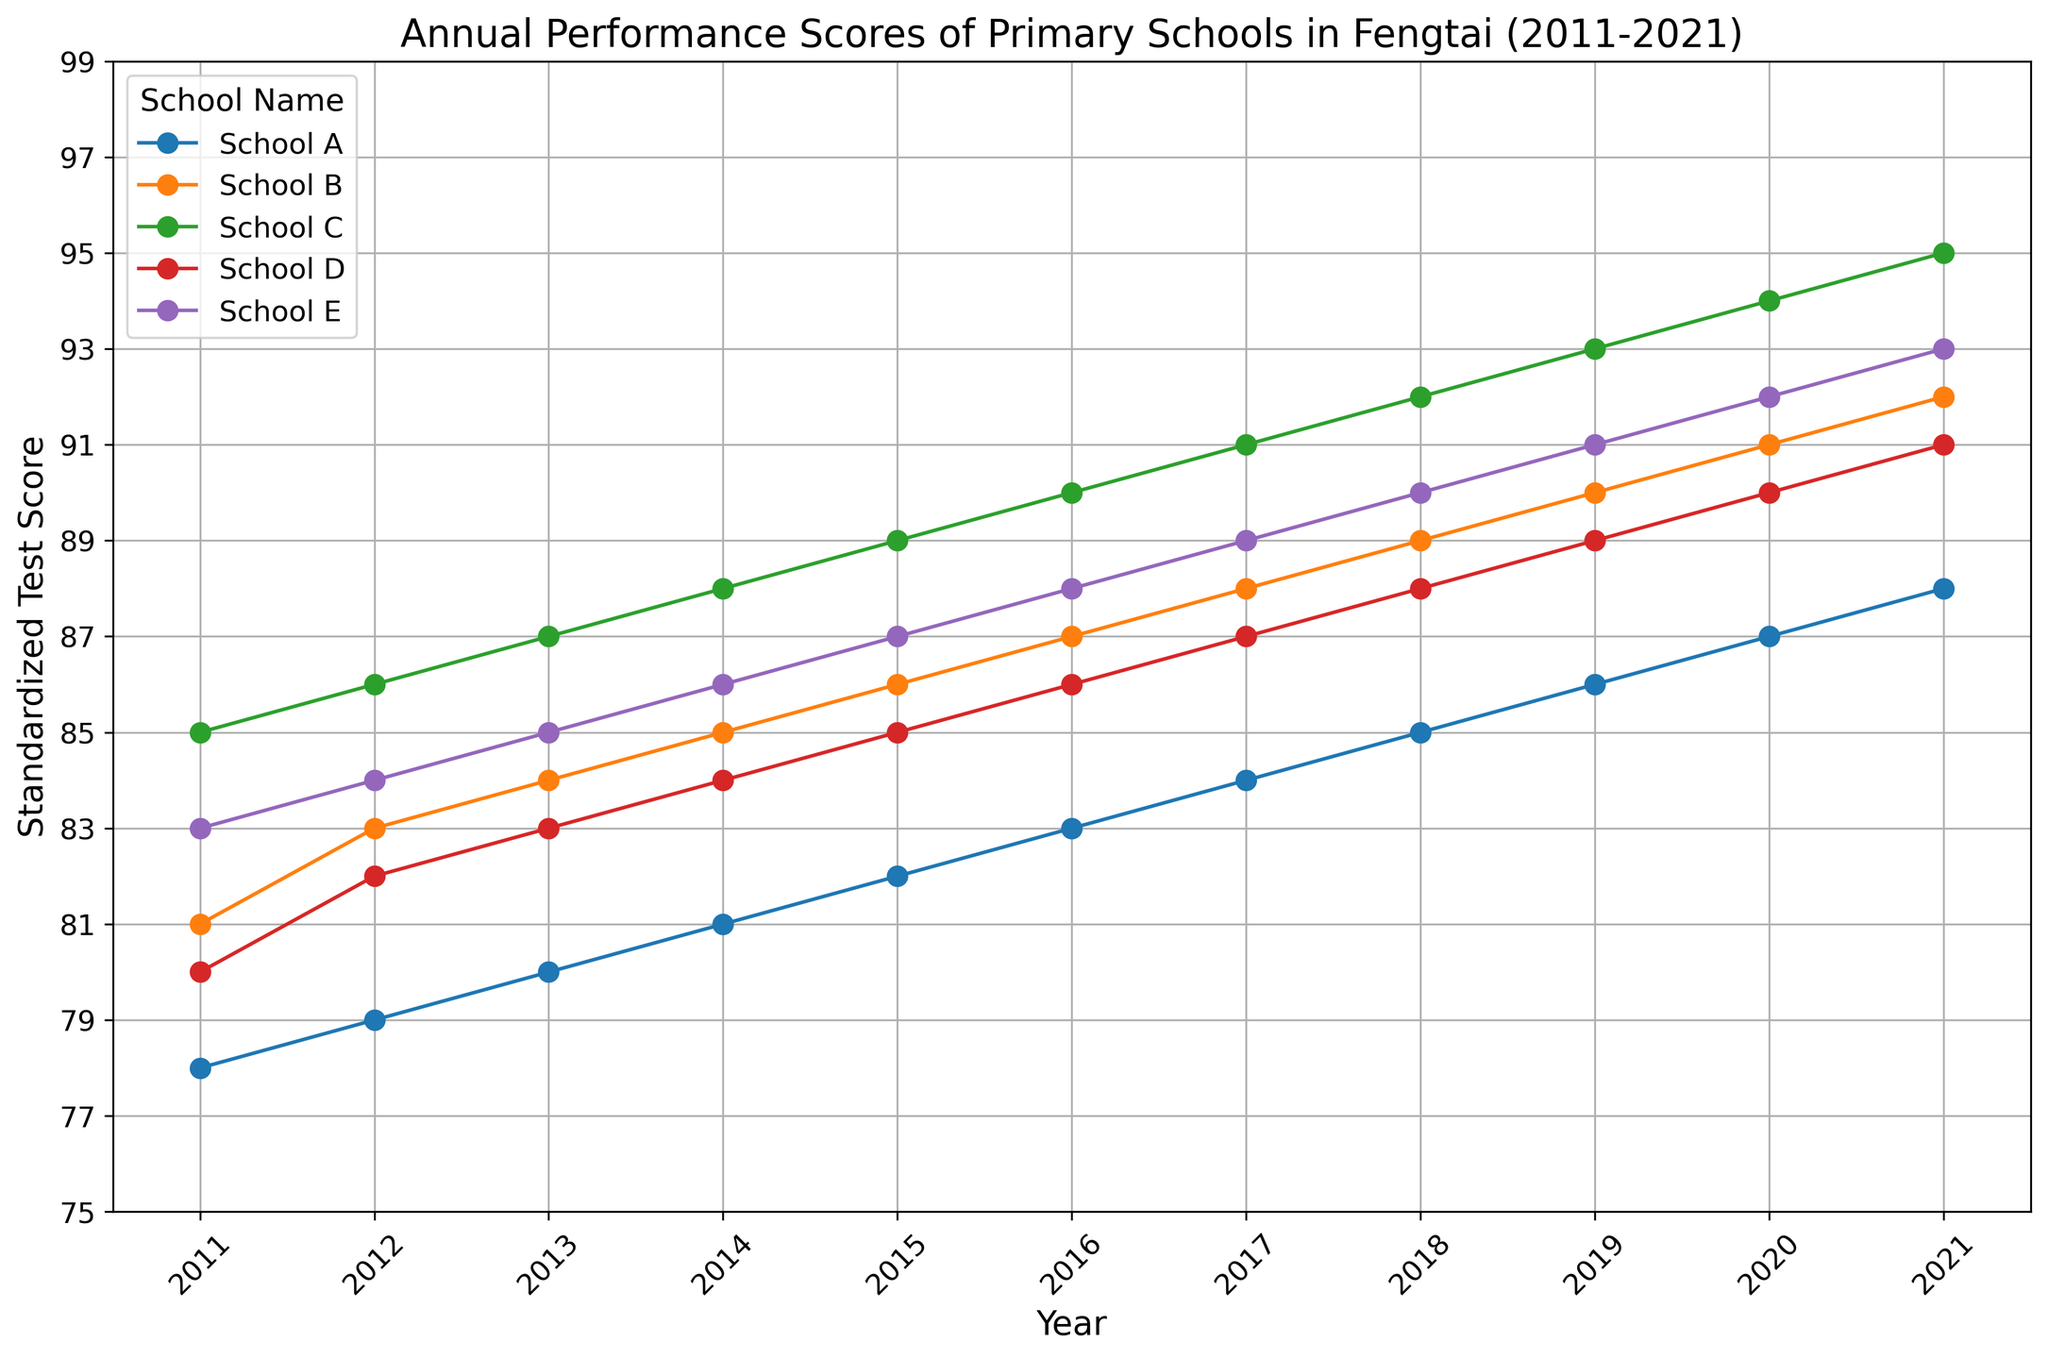What's the trend in standardized test scores for School C from 2011 to 2021? Observe the line representing School C. The scores increase consistently from 85 in 2011 to 95 in 2021. This indicates a positive trend.
Answer: Positive trend Which school had the highest standardized test score in 2021? Look at the data points for 2021. School C scores the highest with 95.
Answer: School C Between School B and School D, which school had a better performance in 2018? Refer to the 2018 data points for School B and School D. School B had a score of 89 while School D had 88.
Answer: School B What is the average standardized test score of School A from 2011 to 2021? Sum up the scores of School A from 2011 (78) to 2021 (88), which equals 913. Divide by 11 (number of years). \( \frac{913}{11} \approx 83 \).
Answer: 83 Did any school show a consistently increasing score every year? Check each school's line on the graph. Only School C shows an uninterrupted increase from 2011 to 2021.
Answer: School C How much did School E's score increase by from 2011 to 2021? Subtract School E's 2011 score (83) from its 2021 score (93). \( 93 - 83 = 10 \).
Answer: 10 What is the combined score of School A and School D in 2015? Refer to 2015 scores of School A (82) and School D (85). Add them together. \( 82 + 85 = 167 \).
Answer: 167 Which school had the lowest score in 2011? Check the data points for 2011. School A had the lowest score with 78.
Answer: School A Did School B ever score less than 80 during the period 2011-2021? Examine the graph for School B. The minimum score for School B is 81 in 2011, which is not less than 80.
Answer: No Compare the performance of School D and School E in 2020. Look at the scores for 2020. School D had 90 while School E had 92. School E performed better.
Answer: School E 